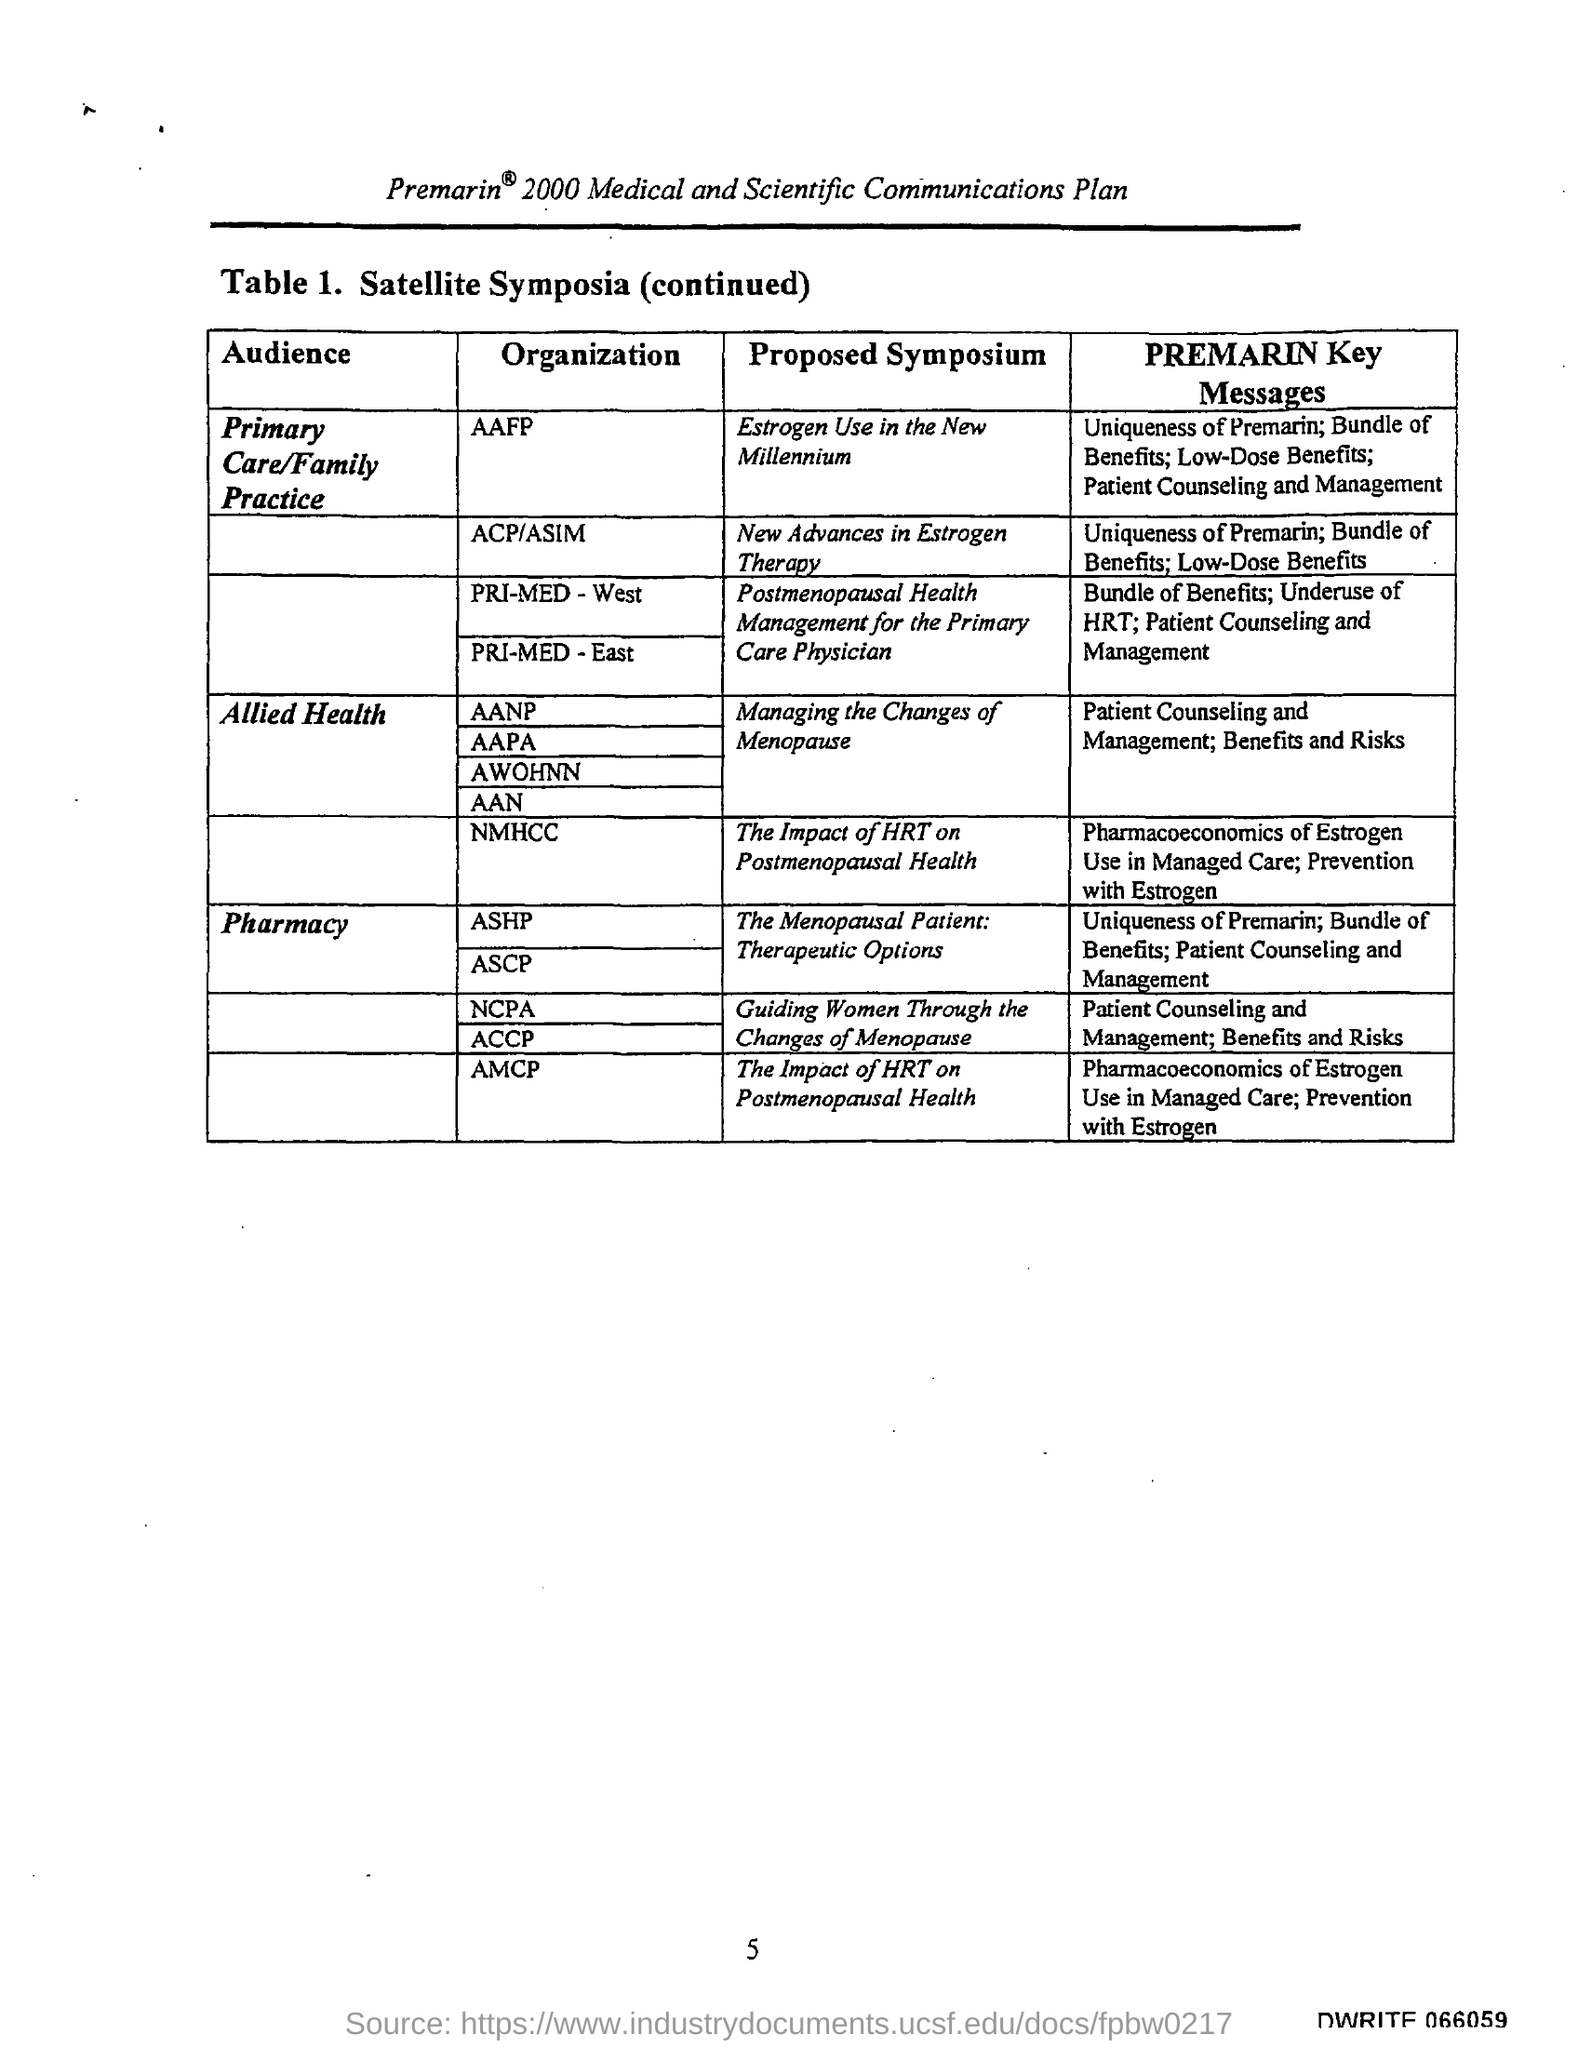What is the title of the Table 1.?
Offer a very short reply. Satellite Symposia. What are the PREMARIN Key Messages for AANP?
Provide a short and direct response. Patient Counseling and Management; Benefits and Risks. What is the page number on this document?
Give a very brief answer. 5. 